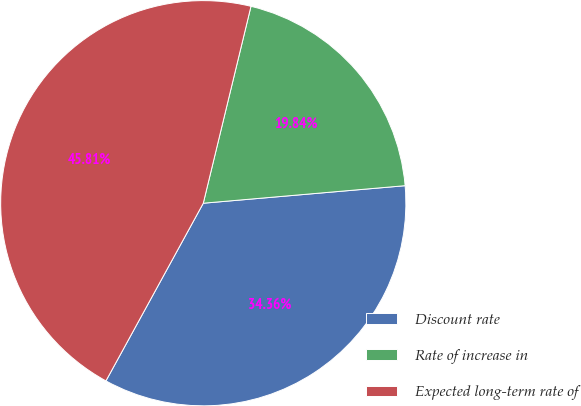Convert chart to OTSL. <chart><loc_0><loc_0><loc_500><loc_500><pie_chart><fcel>Discount rate<fcel>Rate of increase in<fcel>Expected long-term rate of<nl><fcel>34.36%<fcel>19.84%<fcel>45.81%<nl></chart> 